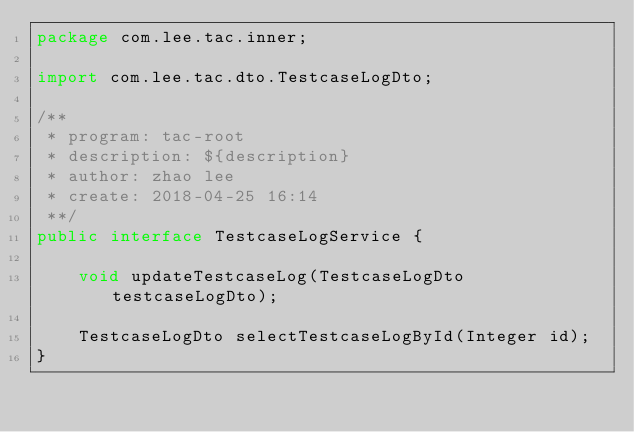<code> <loc_0><loc_0><loc_500><loc_500><_Java_>package com.lee.tac.inner;

import com.lee.tac.dto.TestcaseLogDto;

/**
 * program: tac-root
 * description: ${description}
 * author: zhao lee
 * create: 2018-04-25 16:14
 **/
public interface TestcaseLogService {

    void updateTestcaseLog(TestcaseLogDto testcaseLogDto);

    TestcaseLogDto selectTestcaseLogById(Integer id);
}
</code> 